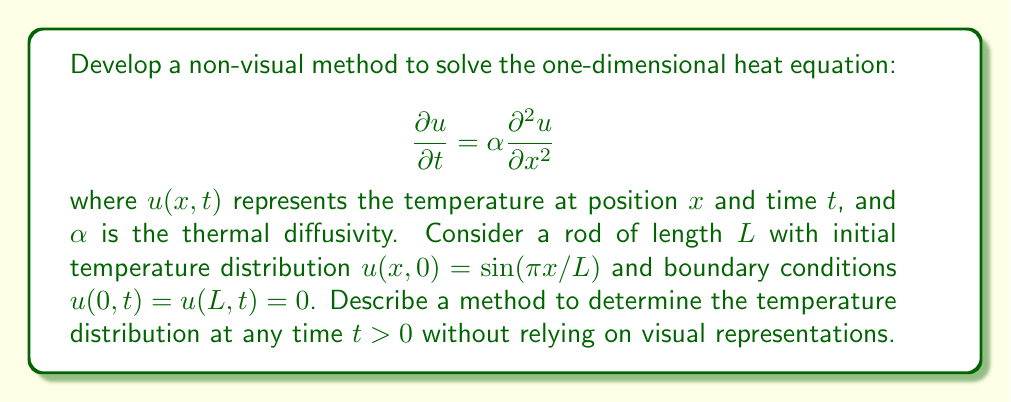Give your solution to this math problem. To solve this problem without visual aids, we can use the separation of variables method and express the solution as a Fourier series. Here's a step-by-step approach:

1. Assume the solution has the form $u(x,t) = X(x)T(t)$.

2. Substitute this into the heat equation:
   $$X(x)T'(t) = \alpha X''(x)T(t)$$

3. Separate variables:
   $$\frac{T'(t)}{T(t)} = \alpha \frac{X''(x)}{X(x)} = -\lambda$$
   where $\lambda$ is a constant.

4. Solve the resulting ODEs:
   $$T(t) = Ce^{-\lambda\alpha t}$$
   $$X(x) = A\sin(\sqrt{\lambda}x) + B\cos(\sqrt{\lambda}x)$$

5. Apply boundary conditions $u(0,t) = u(L,t) = 0$:
   $$X(0) = X(L) = 0$$
   This gives $B = 0$ and $\sqrt{\lambda} = \frac{n\pi}{L}$ for $n = 1, 2, 3, ...$

6. The general solution is a superposition of all possible solutions:
   $$u(x,t) = \sum_{n=1}^{\infty} A_n \sin(\frac{n\pi x}{L}) e^{-(\frac{n\pi}{L})^2\alpha t}$$

7. Apply the initial condition $u(x,0) = \sin(\pi x/L)$:
   $$\sin(\frac{\pi x}{L}) = \sum_{n=1}^{\infty} A_n \sin(\frac{n\pi x}{L})$$

8. This implies $A_1 = 1$ and $A_n = 0$ for $n > 1$.

9. Therefore, the final solution is:
   $$u(x,t) = \sin(\frac{\pi x}{L}) e^{-(\frac{\pi}{L})^2\alpha t}$$

This method relies on analytical expressions and series expansions, which can be communicated verbally or through tactile representations of equations, making it accessible for visually impaired individuals.
Answer: $u(x,t) = \sin(\frac{\pi x}{L}) e^{-(\frac{\pi}{L})^2\alpha t}$ 